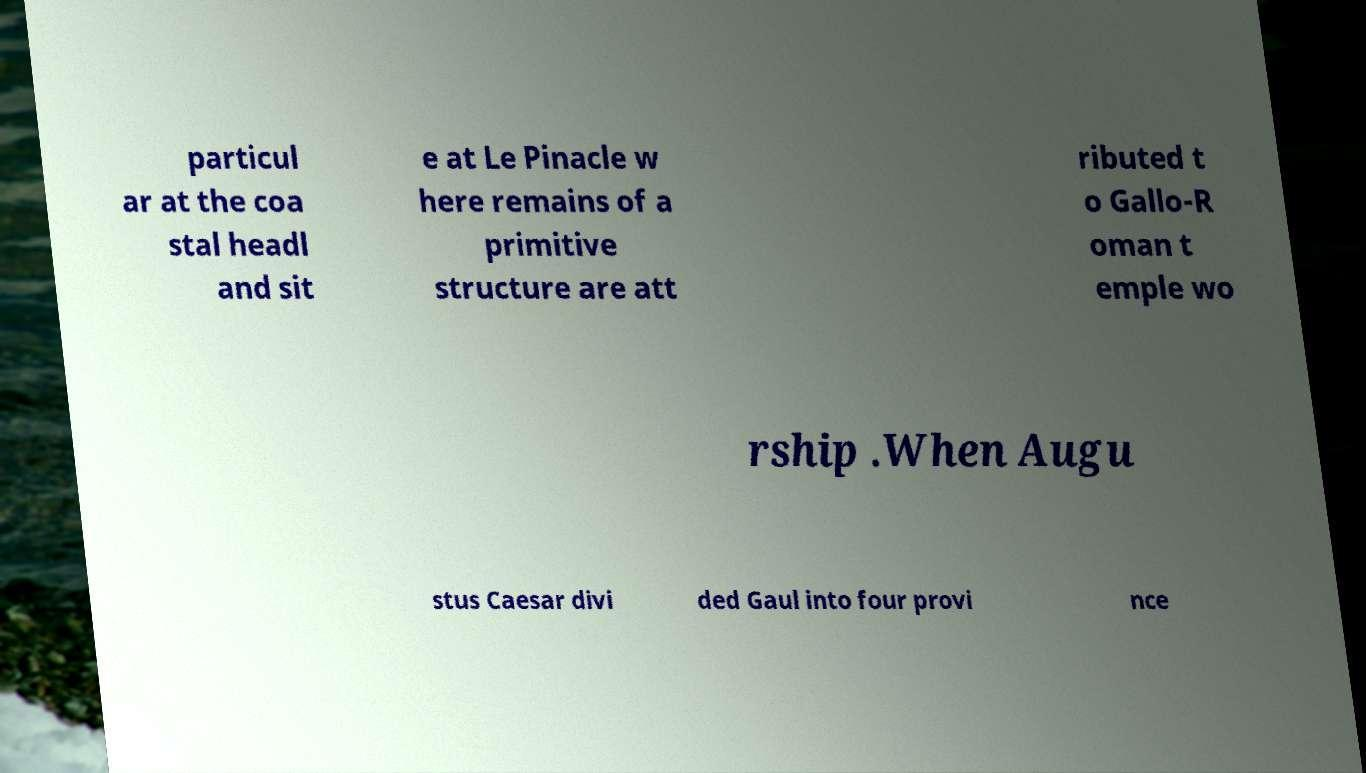There's text embedded in this image that I need extracted. Can you transcribe it verbatim? particul ar at the coa stal headl and sit e at Le Pinacle w here remains of a primitive structure are att ributed t o Gallo-R oman t emple wo rship .When Augu stus Caesar divi ded Gaul into four provi nce 